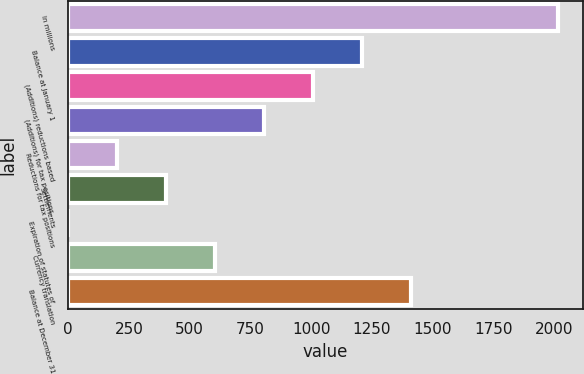<chart> <loc_0><loc_0><loc_500><loc_500><bar_chart><fcel>In millions<fcel>Balance at January 1<fcel>(Additions) reductions based<fcel>(Additions) for tax positions<fcel>Reductions for tax positions<fcel>Settlements<fcel>Expiration of statutes of<fcel>Currency translation<fcel>Balance at December 31<nl><fcel>2017<fcel>1210.6<fcel>1009<fcel>807.4<fcel>202.6<fcel>404.2<fcel>1<fcel>605.8<fcel>1412.2<nl></chart> 